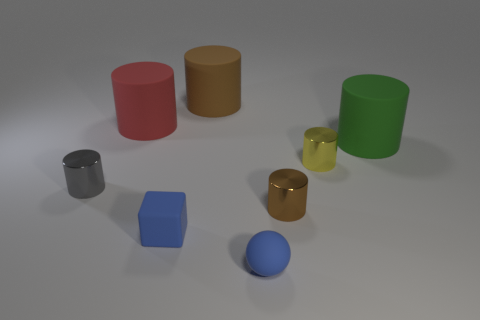Subtract all brown cylinders. How many were subtracted if there are1brown cylinders left? 1 Subtract 3 cylinders. How many cylinders are left? 3 Add 2 small yellow objects. How many objects exist? 10 Subtract all red cylinders. How many cylinders are left? 5 Subtract all tiny gray shiny cylinders. How many cylinders are left? 5 Subtract all red cylinders. Subtract all blue balls. How many cylinders are left? 5 Subtract all balls. How many objects are left? 7 Add 2 green cylinders. How many green cylinders are left? 3 Add 6 green rubber cylinders. How many green rubber cylinders exist? 7 Subtract 0 purple spheres. How many objects are left? 8 